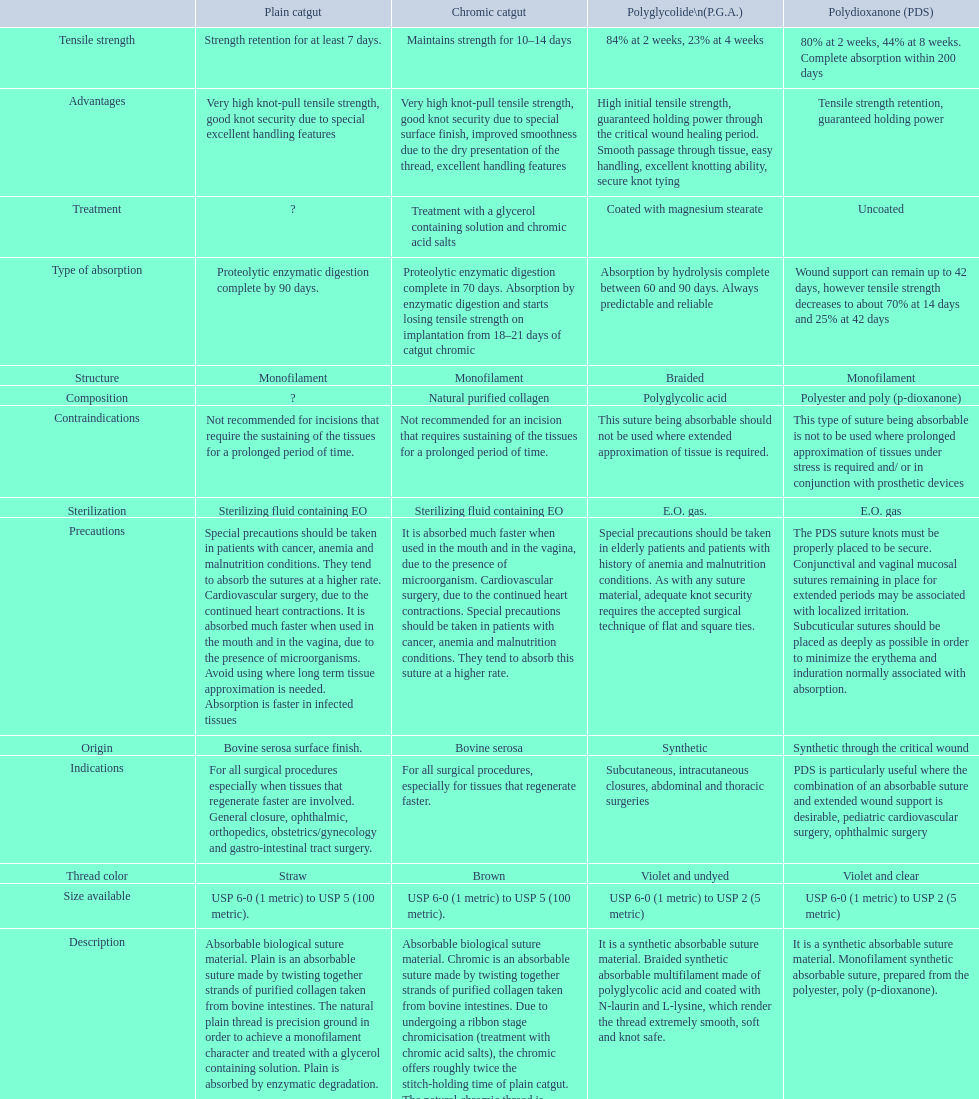Plain catgut and chromic catgut both have what type of structure? Monofilament. 